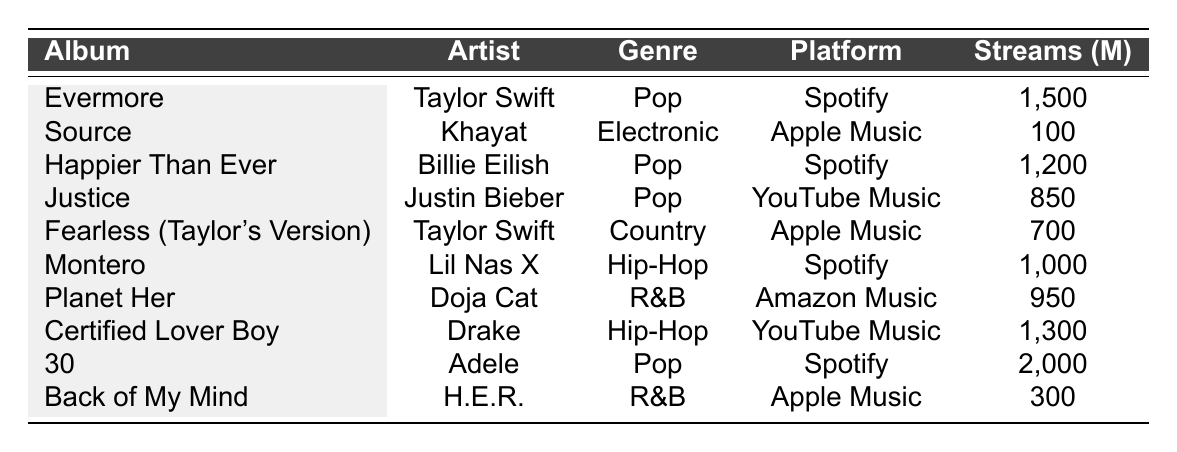What album has the highest total streams? By examining the total streams in the table, "30" by Adele has 2,000 million streams, which is the highest among all listed albums.
Answer: 30 Which artist has more than one album in the table? Looking at the artist column, Taylor Swift appears twice with "Evermore" and "Fearless (Taylor's Version)" albums, thus she has more than one album in the table.
Answer: Yes What is the total number of streams for Pop genre albums? The Pop genre albums in the table are "Evermore," "Happier Than Ever," "Justice," and "30." Their total streams are (1,500 + 1,200 + 850 + 2,000) = 5,550 million streams.
Answer: 5,550 million Which streaming platform has the least number of streams for a single album? Among the listed albums, "Source" by Khayat on Apple Music has the least streams at 100 million.
Answer: Apple Music What is the average number of monthly listeners across all albums? To find the average, sum the monthly listeners (22,000,000 + 8,000,000 + 19,000,000 + 11,000,000 + 9,000,000 + 13,000,000 + 10,000,000 + 16,000,000 + 25,000,000 + 6,000,000) = 139,000,000, then divide by 10 (the number of albums) resulting in 13,900,000 average monthly listeners.
Answer: 13,900,000 Which genre has the highest number of monthly listeners in a single album? "30" by Adele in the Pop genre has the highest monthly listeners with 25,000,000, more than any other album listed.
Answer: Pop Is "Planet Her" by Doja Cat more popular on Amazon Music than "Back of My Mind" by H.E.R. on Apple Music? "Planet Her" has 950 million streams on Amazon Music while "Back of My Mind" has 300 million streams on Apple Music, making "Planet Her" more popular.
Answer: Yes What is the combined total streams of Hip-Hop genre albums? The Hip-Hop genre albums are "Montero" and "Certified Lover Boy," with total streams of (1,000 + 1,300) = 2,300 million streams combined.
Answer: 2,300 million 